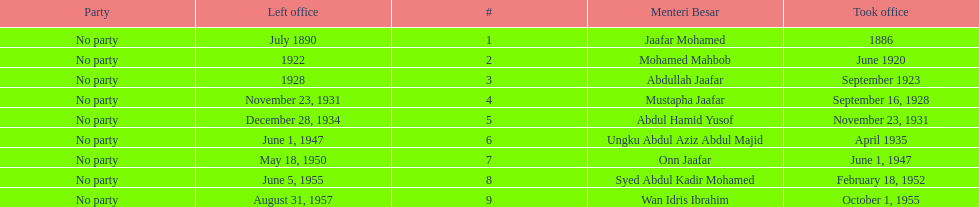What is the number of menteri besar that served 4 or more years? 3. 